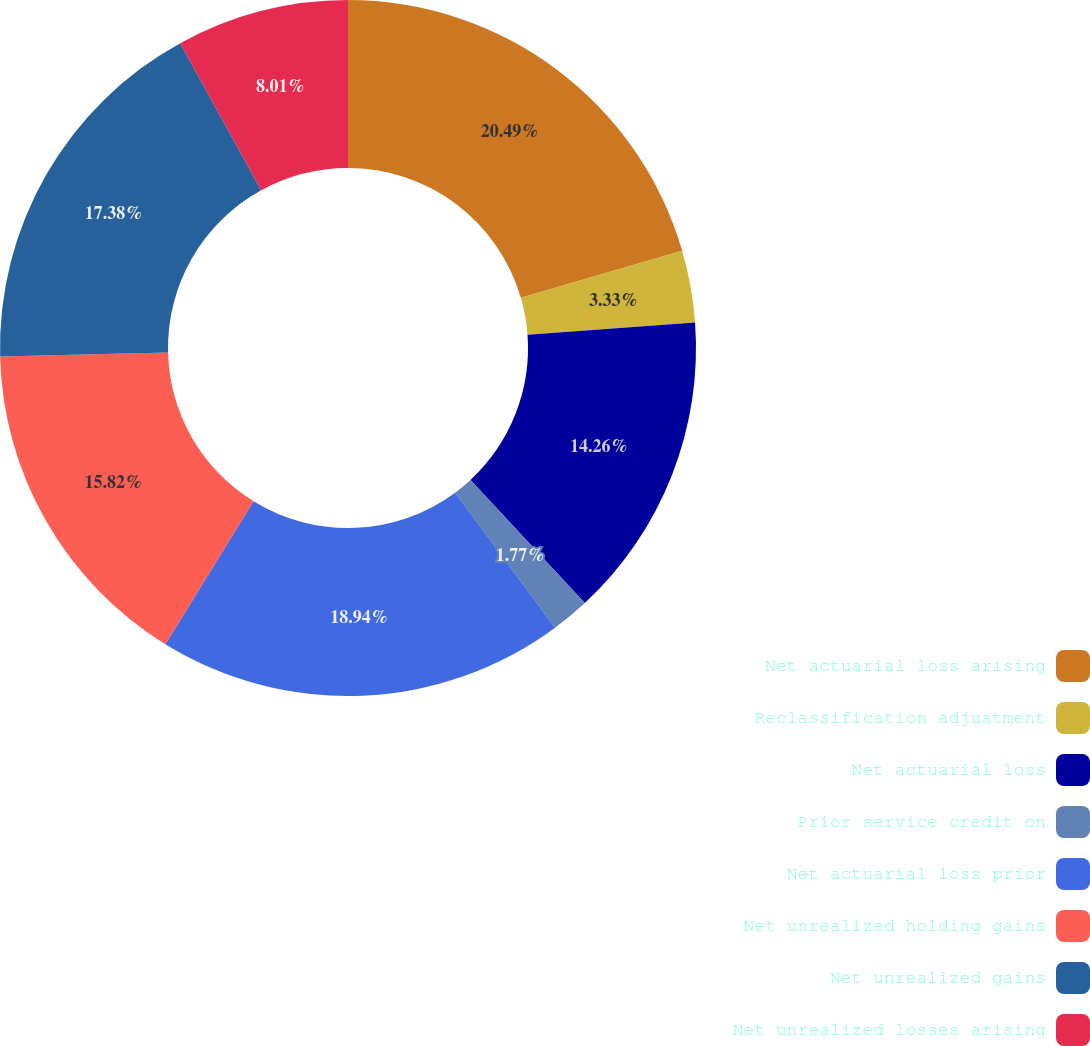Convert chart to OTSL. <chart><loc_0><loc_0><loc_500><loc_500><pie_chart><fcel>Net actuarial loss arising<fcel>Reclassification adjustment<fcel>Net actuarial loss<fcel>Prior service credit on<fcel>Net actuarial loss prior<fcel>Net unrealized holding gains<fcel>Net unrealized gains<fcel>Net unrealized losses arising<nl><fcel>20.5%<fcel>3.33%<fcel>14.26%<fcel>1.77%<fcel>18.94%<fcel>15.82%<fcel>17.38%<fcel>8.01%<nl></chart> 